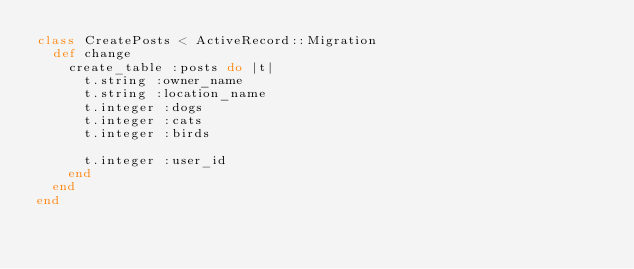Convert code to text. <code><loc_0><loc_0><loc_500><loc_500><_Ruby_>class CreatePosts < ActiveRecord::Migration
  def change
    create_table :posts do |t|
      t.string :owner_name
      t.string :location_name 
      t.integer :dogs 
      t.integer :cats 
      t.integer :birds
      
      t.integer :user_id
    end
  end
end
</code> 